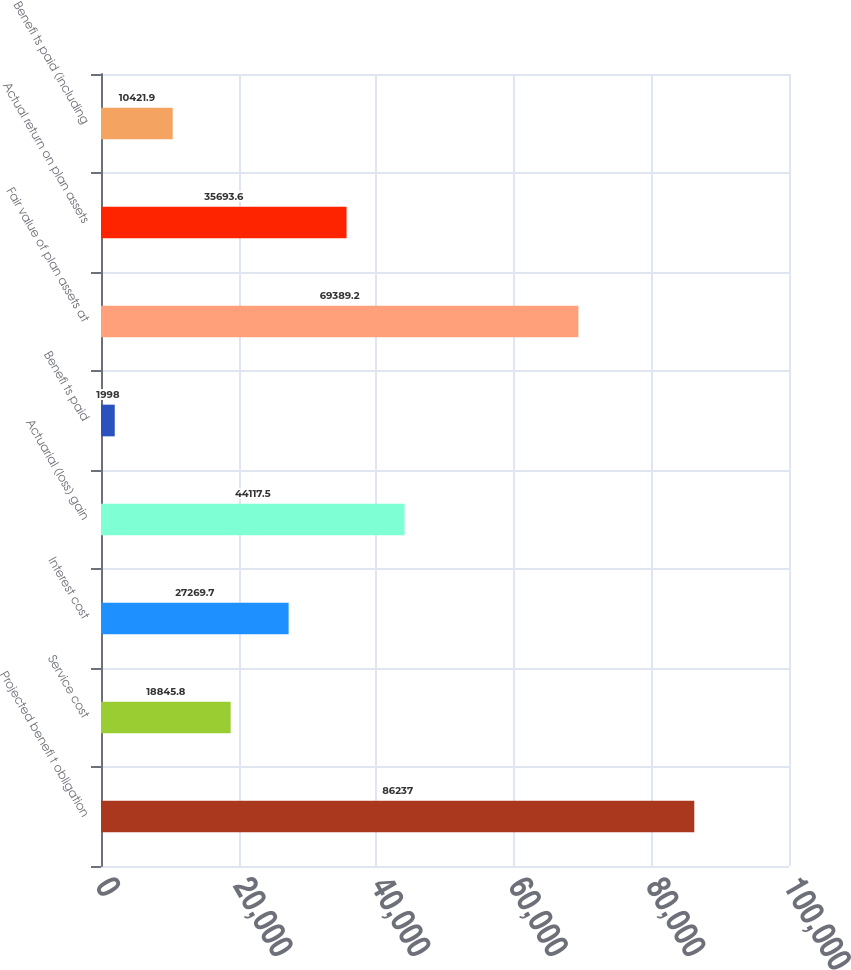Convert chart to OTSL. <chart><loc_0><loc_0><loc_500><loc_500><bar_chart><fcel>Projected benefi t obligation<fcel>Service cost<fcel>Interest cost<fcel>Actuarial (loss) gain<fcel>Benefi ts paid<fcel>Fair value of plan assets at<fcel>Actual return on plan assets<fcel>Benefi ts paid (including<nl><fcel>86237<fcel>18845.8<fcel>27269.7<fcel>44117.5<fcel>1998<fcel>69389.2<fcel>35693.6<fcel>10421.9<nl></chart> 